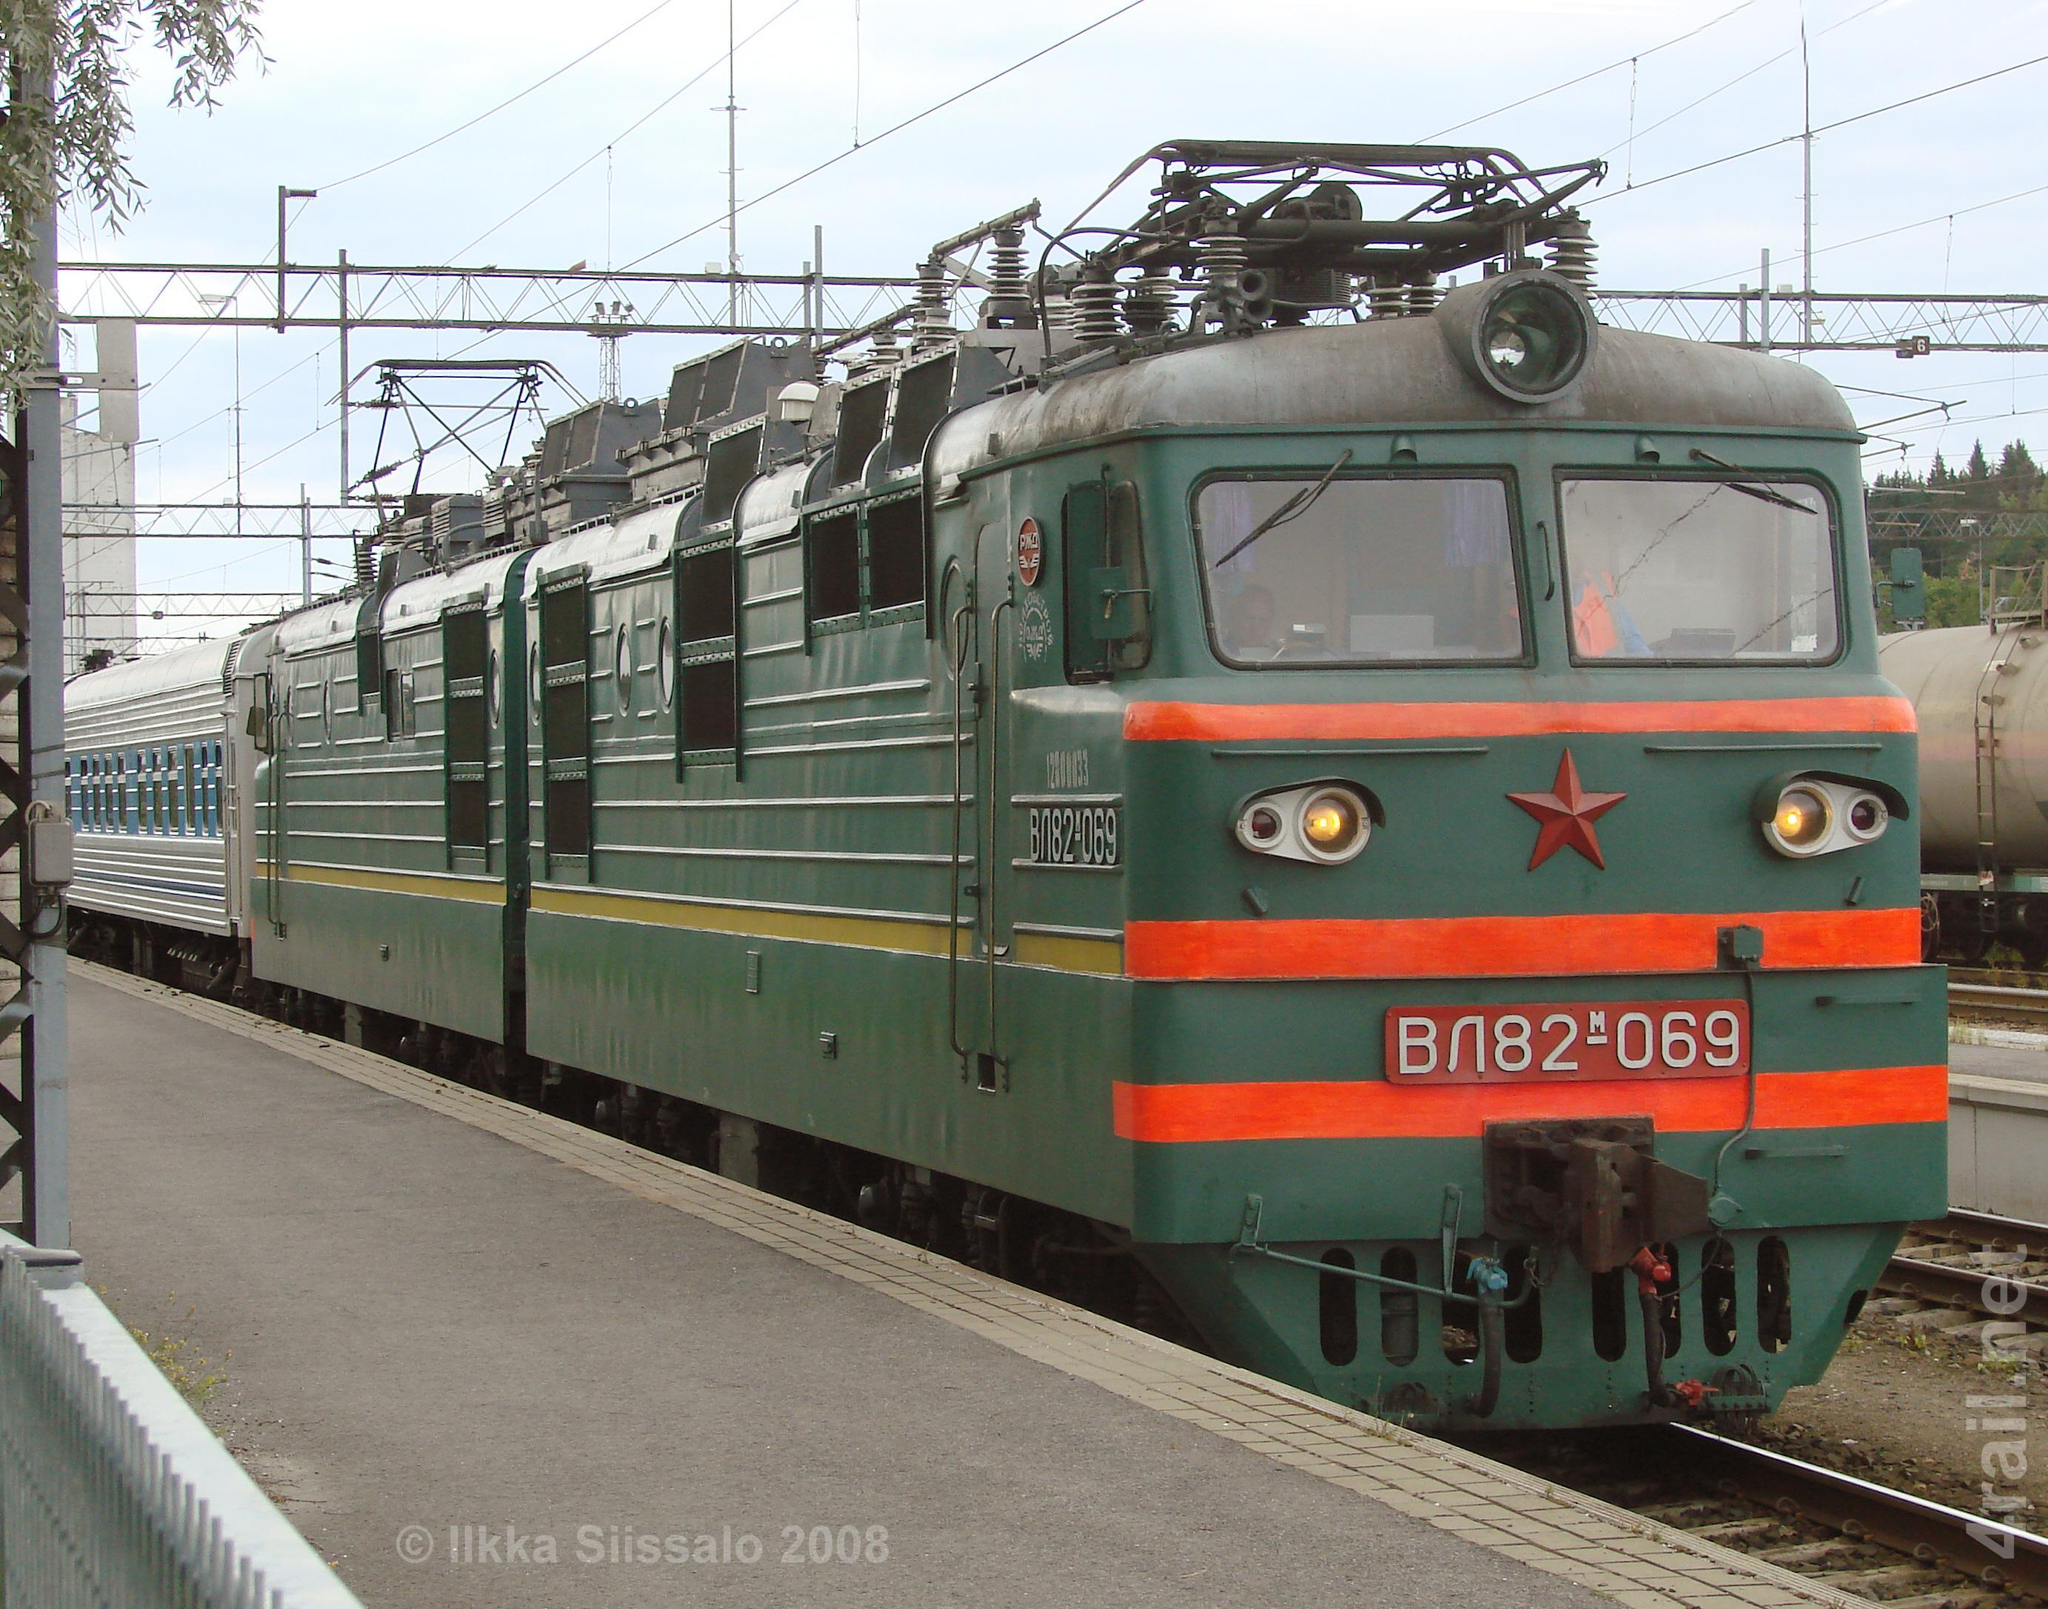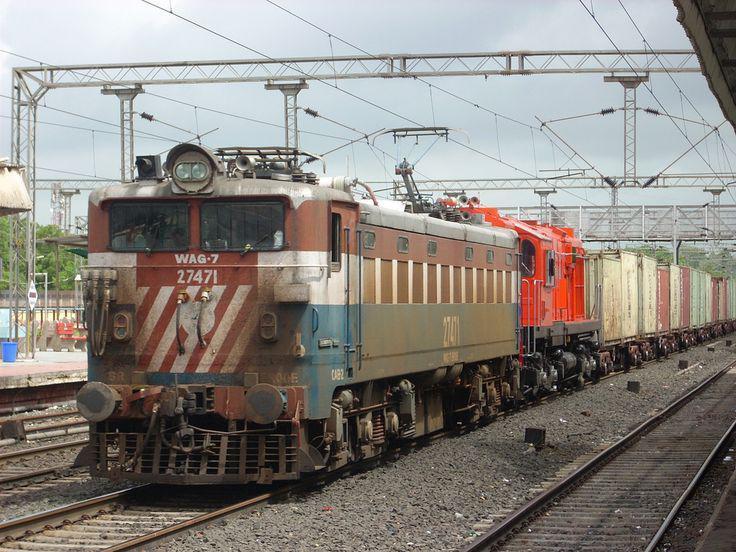The first image is the image on the left, the second image is the image on the right. Considering the images on both sides, is "Two trains are angled so as to travel in the same direction when they move." valid? Answer yes or no. No. 